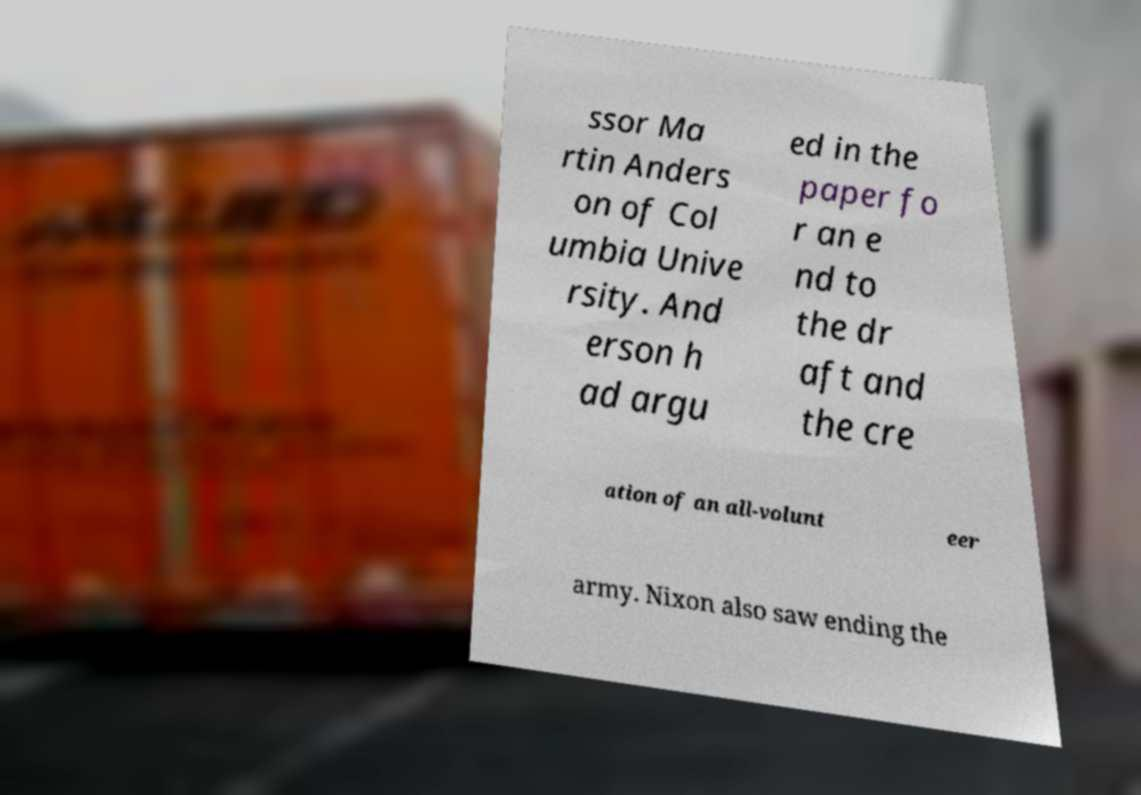Can you accurately transcribe the text from the provided image for me? ssor Ma rtin Anders on of Col umbia Unive rsity. And erson h ad argu ed in the paper fo r an e nd to the dr aft and the cre ation of an all-volunt eer army. Nixon also saw ending the 